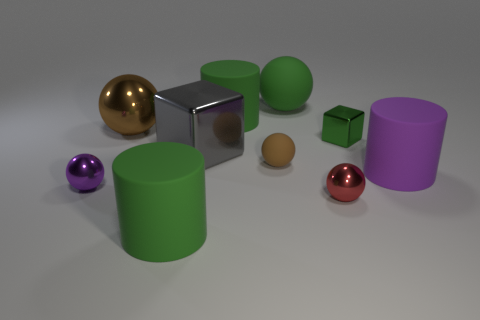Subtract all red balls. How many balls are left? 4 Subtract all purple metallic balls. How many balls are left? 4 Subtract all yellow balls. Subtract all purple cylinders. How many balls are left? 5 Subtract all cubes. How many objects are left? 8 Subtract 1 purple cylinders. How many objects are left? 9 Subtract all green matte cylinders. Subtract all tiny purple metal things. How many objects are left? 7 Add 1 tiny purple objects. How many tiny purple objects are left? 2 Add 3 small blue shiny cubes. How many small blue shiny cubes exist? 3 